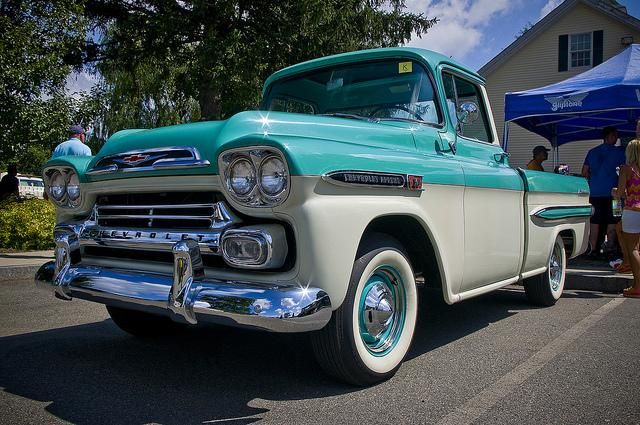What type of vehicle is shown? truck 